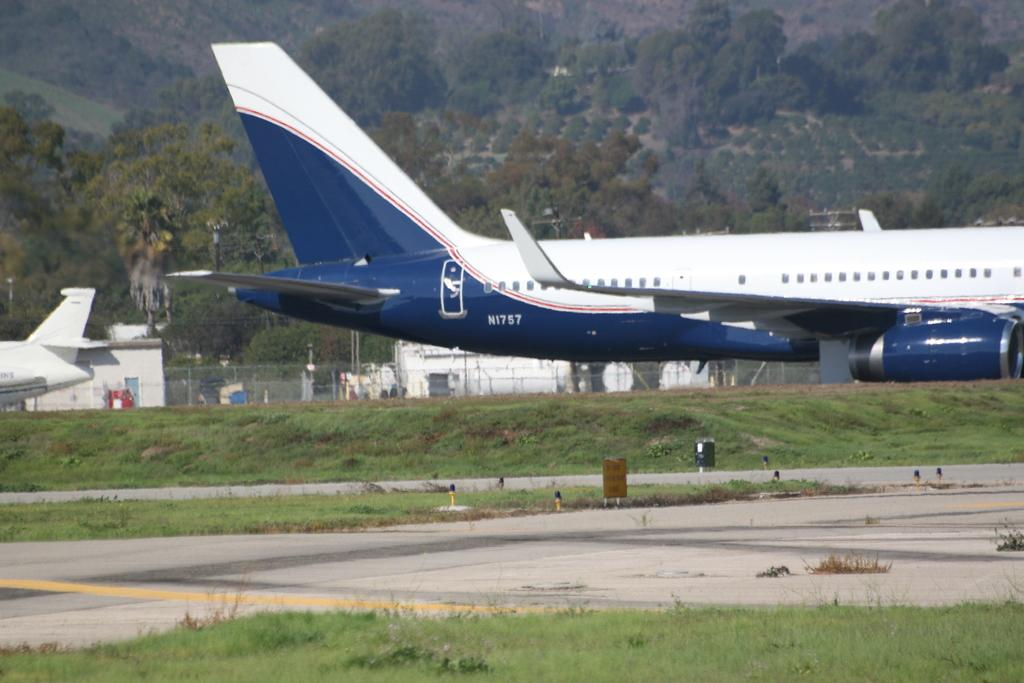<image>
Give a short and clear explanation of the subsequent image. a white and blue plane numbered N1757 on a runway 